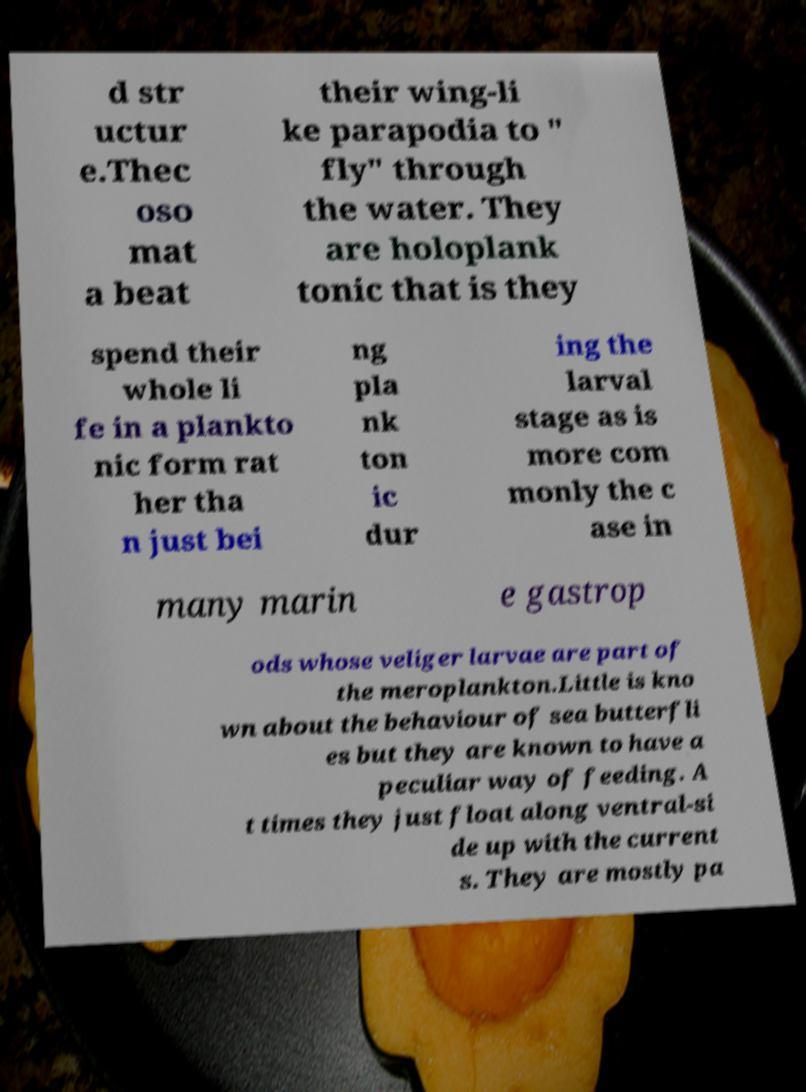I need the written content from this picture converted into text. Can you do that? d str uctur e.Thec oso mat a beat their wing-li ke parapodia to " fly" through the water. They are holoplank tonic that is they spend their whole li fe in a plankto nic form rat her tha n just bei ng pla nk ton ic dur ing the larval stage as is more com monly the c ase in many marin e gastrop ods whose veliger larvae are part of the meroplankton.Little is kno wn about the behaviour of sea butterfli es but they are known to have a peculiar way of feeding. A t times they just float along ventral-si de up with the current s. They are mostly pa 